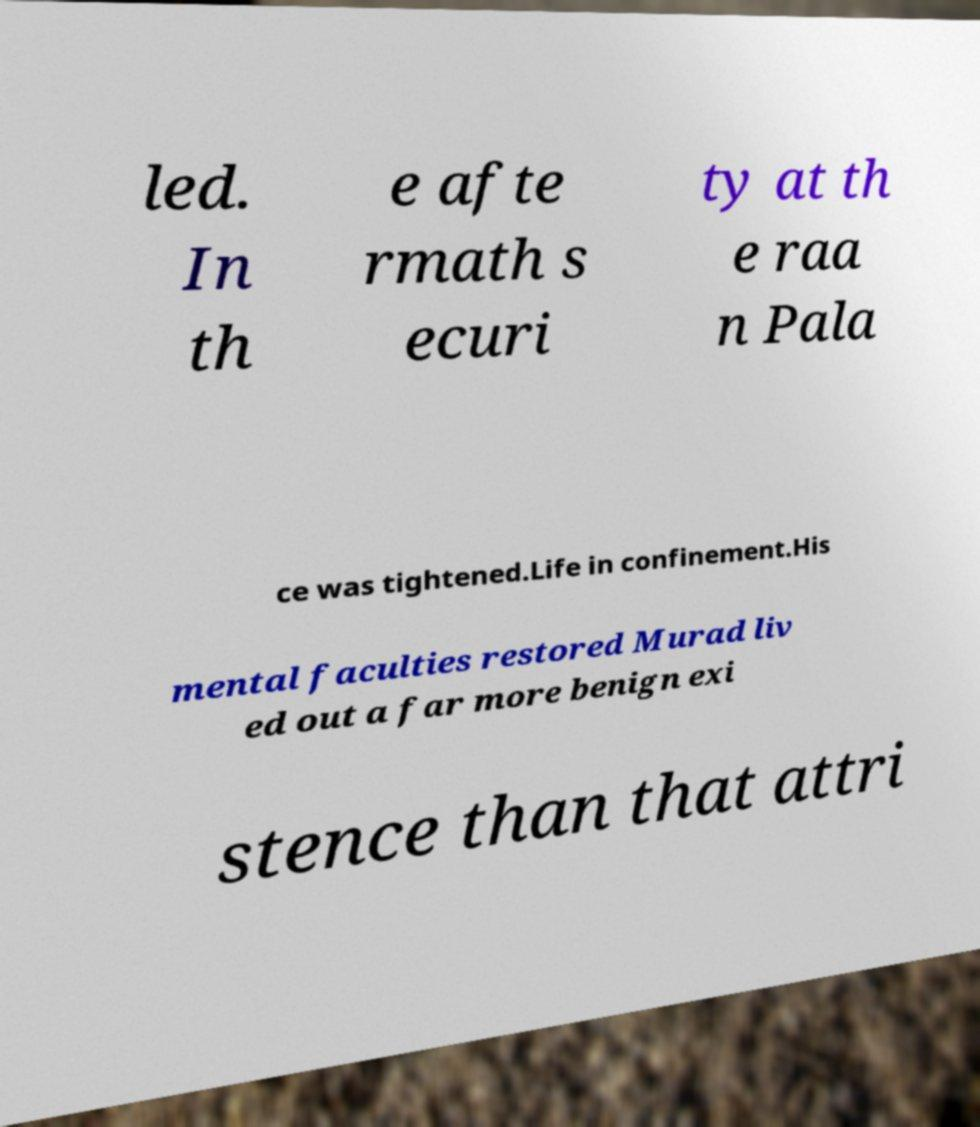There's text embedded in this image that I need extracted. Can you transcribe it verbatim? led. In th e afte rmath s ecuri ty at th e raa n Pala ce was tightened.Life in confinement.His mental faculties restored Murad liv ed out a far more benign exi stence than that attri 